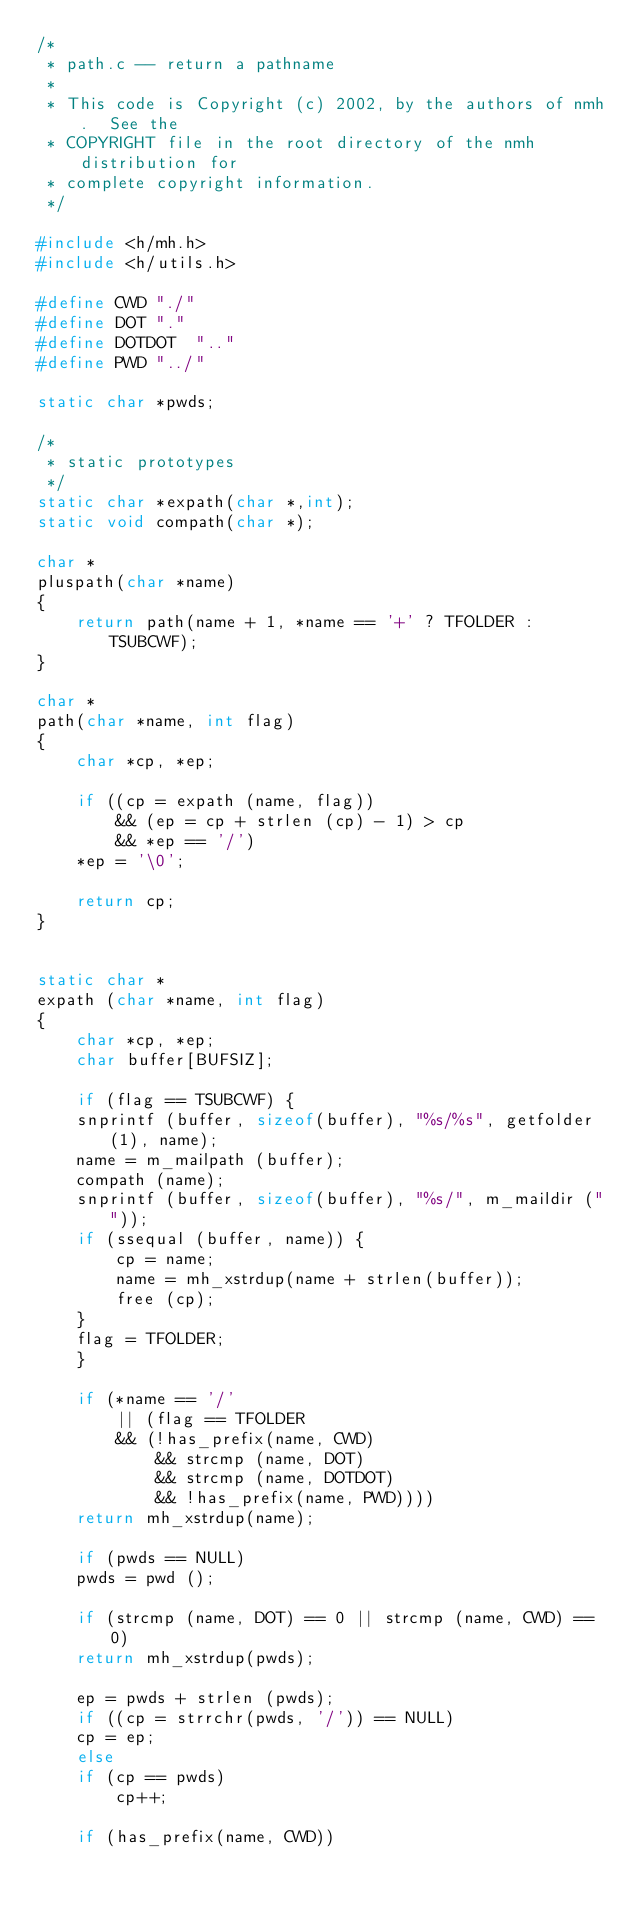<code> <loc_0><loc_0><loc_500><loc_500><_C_>/*
 * path.c -- return a pathname
 *
 * This code is Copyright (c) 2002, by the authors of nmh.  See the
 * COPYRIGHT file in the root directory of the nmh distribution for
 * complete copyright information.
 */

#include <h/mh.h>
#include <h/utils.h>

#define	CWD	"./"
#define	DOT	"."
#define	DOTDOT	".."
#define	PWD	"../"

static char *pwds;

/*
 * static prototypes
 */
static char *expath(char *,int);
static void compath(char *);

char *
pluspath(char *name)
{
	return path(name + 1, *name == '+' ? TFOLDER : TSUBCWF);
}

char *
path(char *name, int flag)
{
    char *cp, *ep;

    if ((cp = expath (name, flag))
	    && (ep = cp + strlen (cp) - 1) > cp
	    && *ep == '/')
	*ep = '\0';

    return cp;
}


static char *
expath (char *name, int flag)
{
    char *cp, *ep;
    char buffer[BUFSIZ];

    if (flag == TSUBCWF) {
	snprintf (buffer, sizeof(buffer), "%s/%s", getfolder (1), name);
	name = m_mailpath (buffer);
	compath (name);
	snprintf (buffer, sizeof(buffer), "%s/", m_maildir (""));
	if (ssequal (buffer, name)) {
	    cp = name;
	    name = mh_xstrdup(name + strlen(buffer));
	    free (cp);
	}
	flag = TFOLDER;
    }

    if (*name == '/'
	    || (flag == TFOLDER
		&& (!has_prefix(name, CWD)
		    && strcmp (name, DOT)
		    && strcmp (name, DOTDOT)
		    && !has_prefix(name, PWD))))
	return mh_xstrdup(name);

    if (pwds == NULL)
	pwds = pwd ();

    if (strcmp (name, DOT) == 0 || strcmp (name, CWD) == 0)
	return mh_xstrdup(pwds);

    ep = pwds + strlen (pwds);
    if ((cp = strrchr(pwds, '/')) == NULL)
	cp = ep;
    else
	if (cp == pwds)
	    cp++;

    if (has_prefix(name, CWD))</code> 